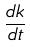<formula> <loc_0><loc_0><loc_500><loc_500>\frac { d k } { d t }</formula> 